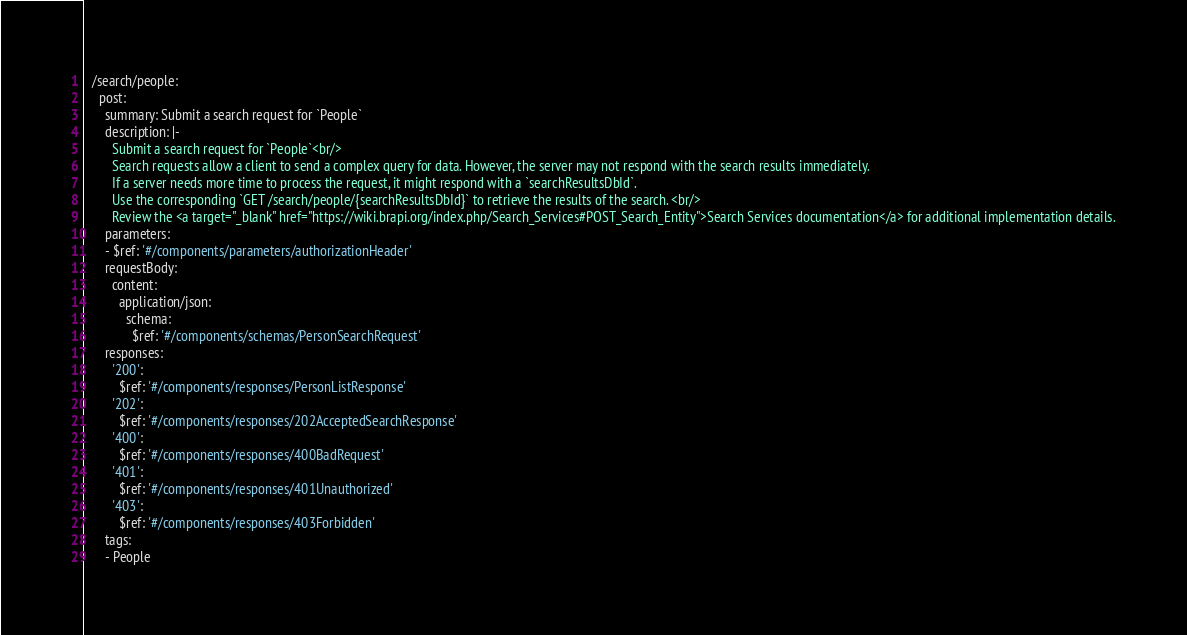Convert code to text. <code><loc_0><loc_0><loc_500><loc_500><_YAML_>  /search/people:
    post:
      summary: Submit a search request for `People`
      description: |-
        Submit a search request for `People`<br/>
        Search requests allow a client to send a complex query for data. However, the server may not respond with the search results immediately. 
        If a server needs more time to process the request, it might respond with a `searchResultsDbId`. 
        Use the corresponding `GET /search/people/{searchResultsDbId}` to retrieve the results of the search. <br/> 
        Review the <a target="_blank" href="https://wiki.brapi.org/index.php/Search_Services#POST_Search_Entity">Search Services documentation</a> for additional implementation details.
      parameters:
      - $ref: '#/components/parameters/authorizationHeader'
      requestBody:
        content:
          application/json:
            schema:
              $ref: '#/components/schemas/PersonSearchRequest'
      responses:
        '200':
          $ref: '#/components/responses/PersonListResponse'
        '202':
          $ref: '#/components/responses/202AcceptedSearchResponse'
        '400':
          $ref: '#/components/responses/400BadRequest'
        '401':
          $ref: '#/components/responses/401Unauthorized'
        '403':
          $ref: '#/components/responses/403Forbidden'
      tags:
      - People
</code> 